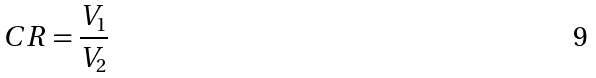<formula> <loc_0><loc_0><loc_500><loc_500>C R = \frac { V _ { 1 } } { V _ { 2 } }</formula> 